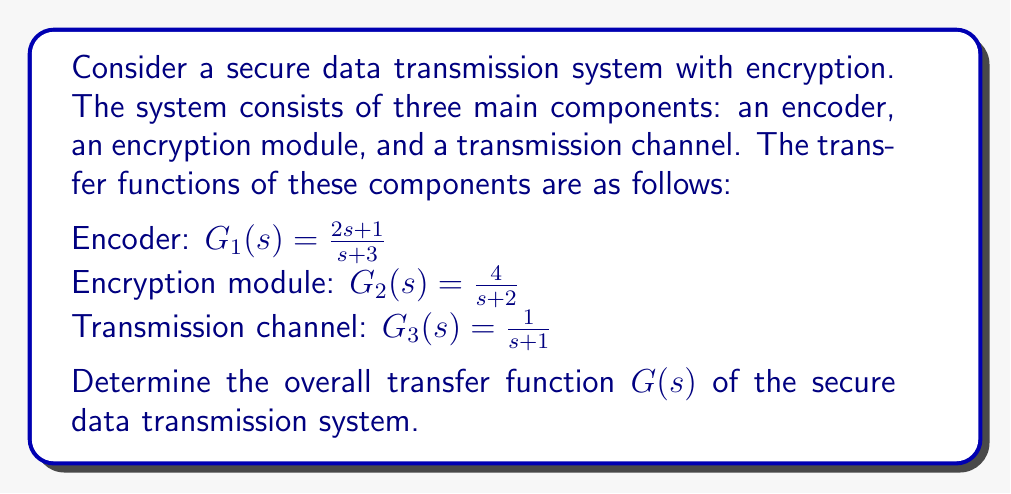Show me your answer to this math problem. To determine the overall transfer function of the secure data transmission system, we need to combine the transfer functions of the individual components. In this case, the components are connected in series, so we multiply their transfer functions.

Let's proceed step by step:

1) The overall transfer function $G(s)$ is the product of $G_1(s)$, $G_2(s)$, and $G_3(s)$:

   $G(s) = G_1(s) \cdot G_2(s) \cdot G_3(s)$

2) Substituting the given transfer functions:

   $G(s) = \frac{2s+1}{s+3} \cdot \frac{4}{s+2} \cdot \frac{1}{s+1}$

3) Multiplying the numerators and denominators:

   $G(s) = \frac{(2s+1) \cdot 4 \cdot 1}{(s+3)(s+2)(s+1)}$

4) Simplify the numerator:

   $G(s) = \frac{8s+4}{(s+3)(s+2)(s+1)}$

5) Expand the denominator:

   $G(s) = \frac{8s+4}{s^3 + 6s^2 + 11s + 6}$

This is the overall transfer function of the secure data transmission system.
Answer: $G(s) = \frac{8s+4}{s^3 + 6s^2 + 11s + 6}$ 